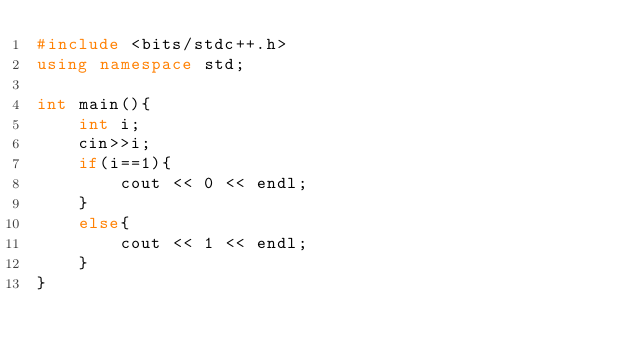Convert code to text. <code><loc_0><loc_0><loc_500><loc_500><_C++_>#include <bits/stdc++.h>
using namespace std;

int main(){
    int i;
    cin>>i;
    if(i==1){
        cout << 0 << endl;
    }
    else{
        cout << 1 << endl;
    }
}</code> 